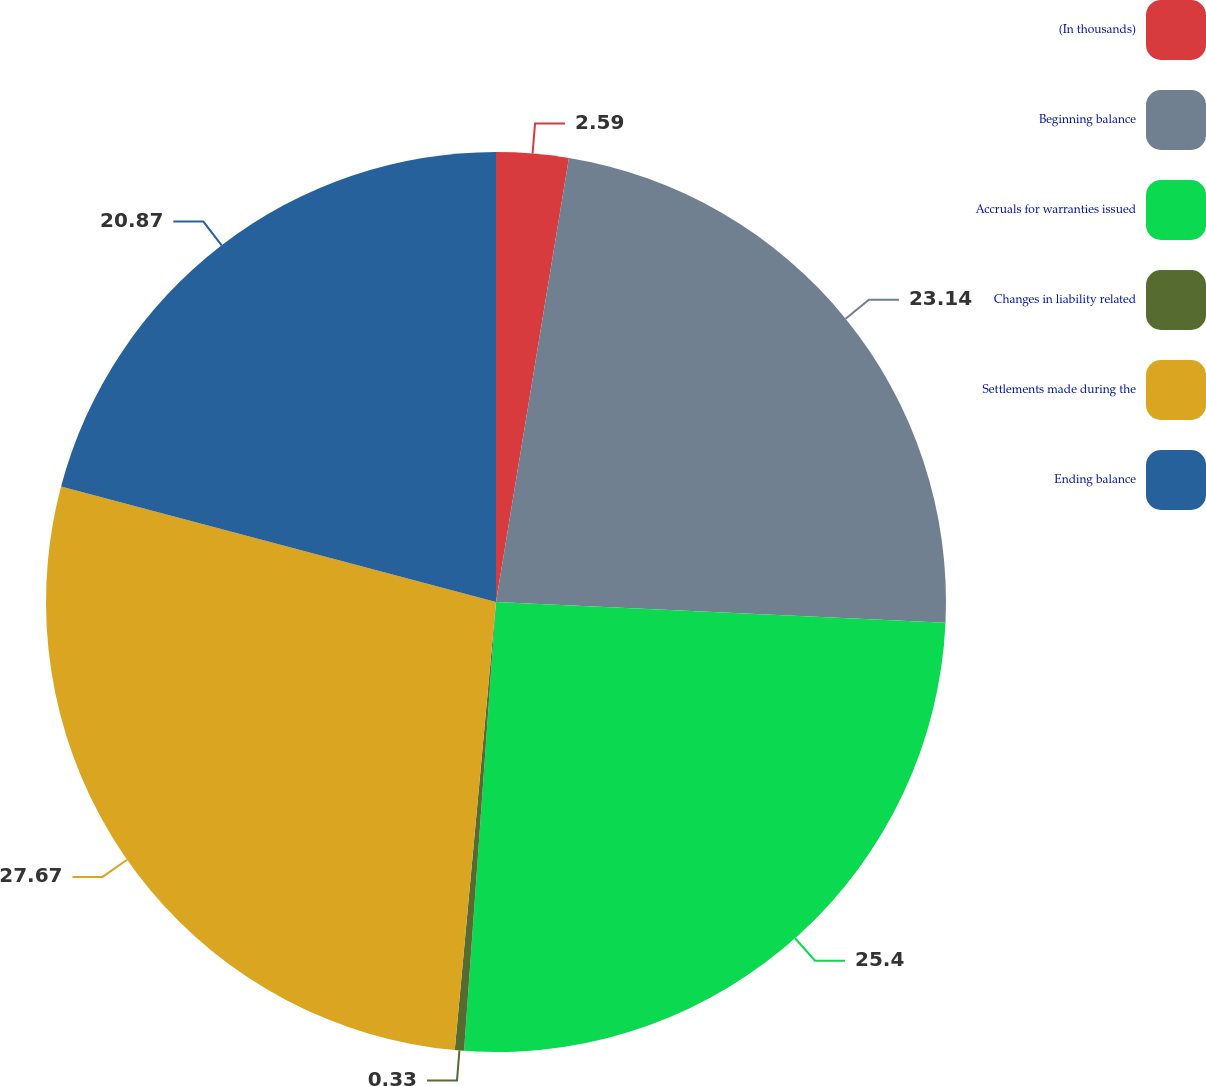<chart> <loc_0><loc_0><loc_500><loc_500><pie_chart><fcel>(In thousands)<fcel>Beginning balance<fcel>Accruals for warranties issued<fcel>Changes in liability related<fcel>Settlements made during the<fcel>Ending balance<nl><fcel>2.59%<fcel>23.14%<fcel>25.4%<fcel>0.33%<fcel>27.67%<fcel>20.87%<nl></chart> 